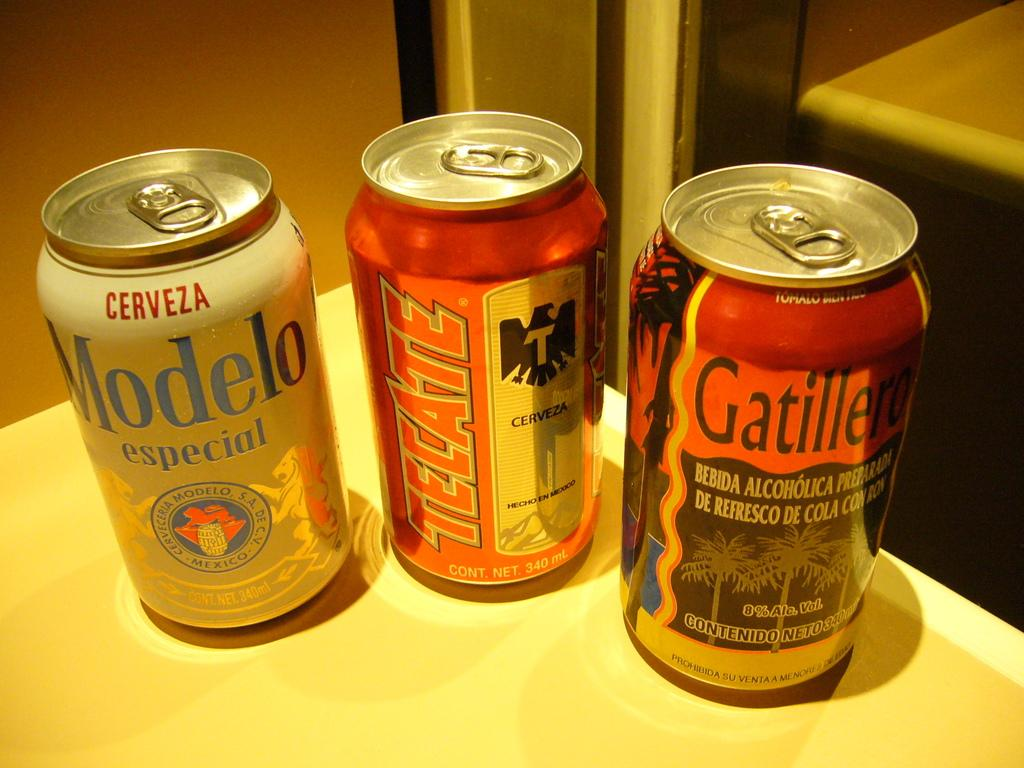Provide a one-sentence caption for the provided image. Modelo, Tecate, and Gatillero beer cans that have not been open yet. 